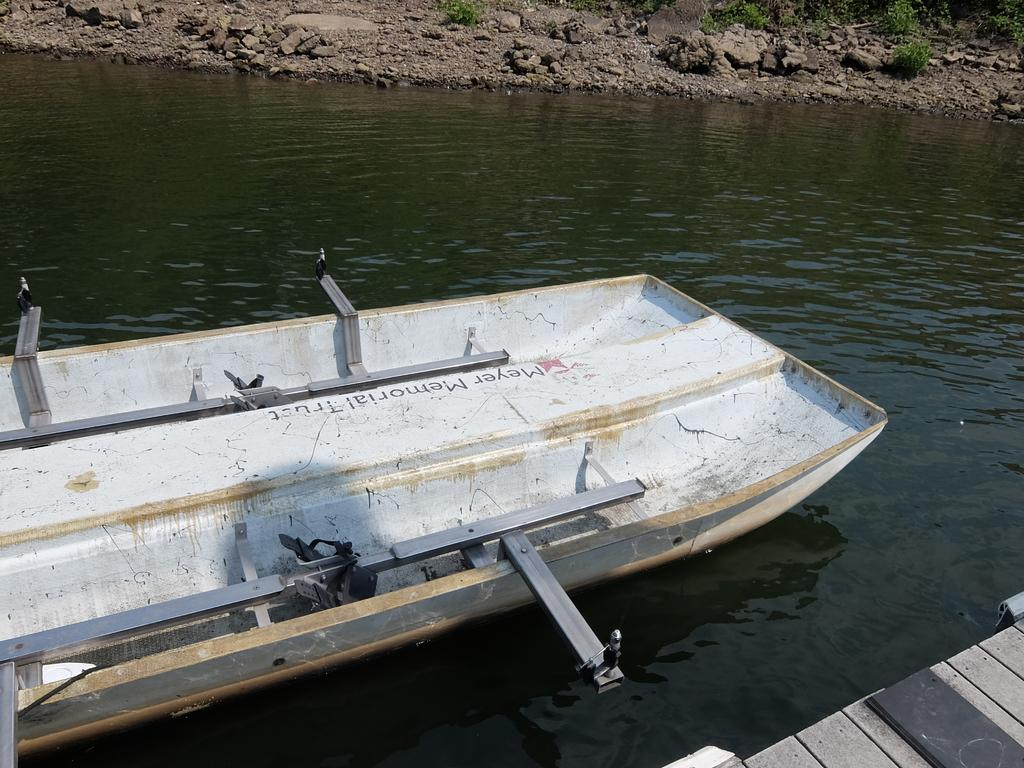What is the color of the boat in the image? The boat in the image is white. Where is the boat located? The boat is in the river water. What can be found on the ground in the image? There are rocks on the ground in the image. Can you see the boat flying in the image? No, the boat is not flying in the image; it is in the river water. 